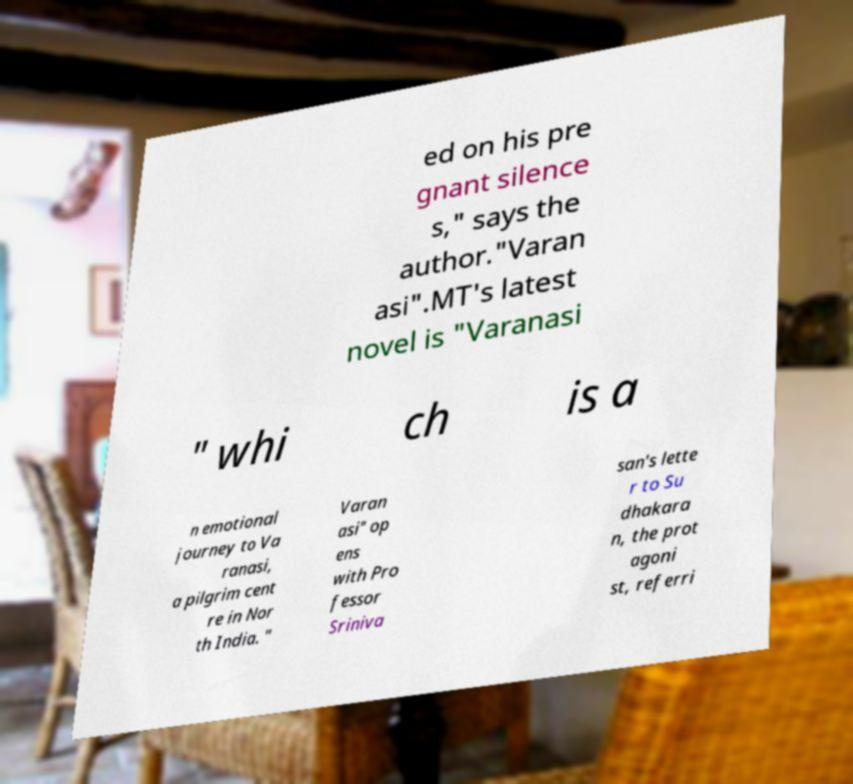There's text embedded in this image that I need extracted. Can you transcribe it verbatim? ed on his pre gnant silence s," says the author."Varan asi".MT's latest novel is "Varanasi " whi ch is a n emotional journey to Va ranasi, a pilgrim cent re in Nor th India. " Varan asi" op ens with Pro fessor Sriniva san's lette r to Su dhakara n, the prot agoni st, referri 